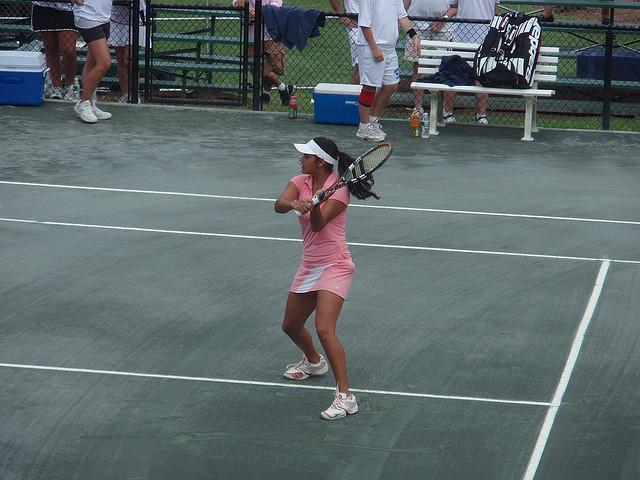What object can keep beverages cold? cooler 